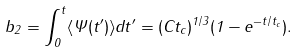Convert formula to latex. <formula><loc_0><loc_0><loc_500><loc_500>b _ { 2 } = \int _ { 0 } ^ { t } \langle \Psi ( t ^ { \prime } ) \rangle d t ^ { \prime } = ( C t _ { c } ) ^ { 1 / 3 } ( 1 - e ^ { - t / t _ { c } } ) .</formula> 